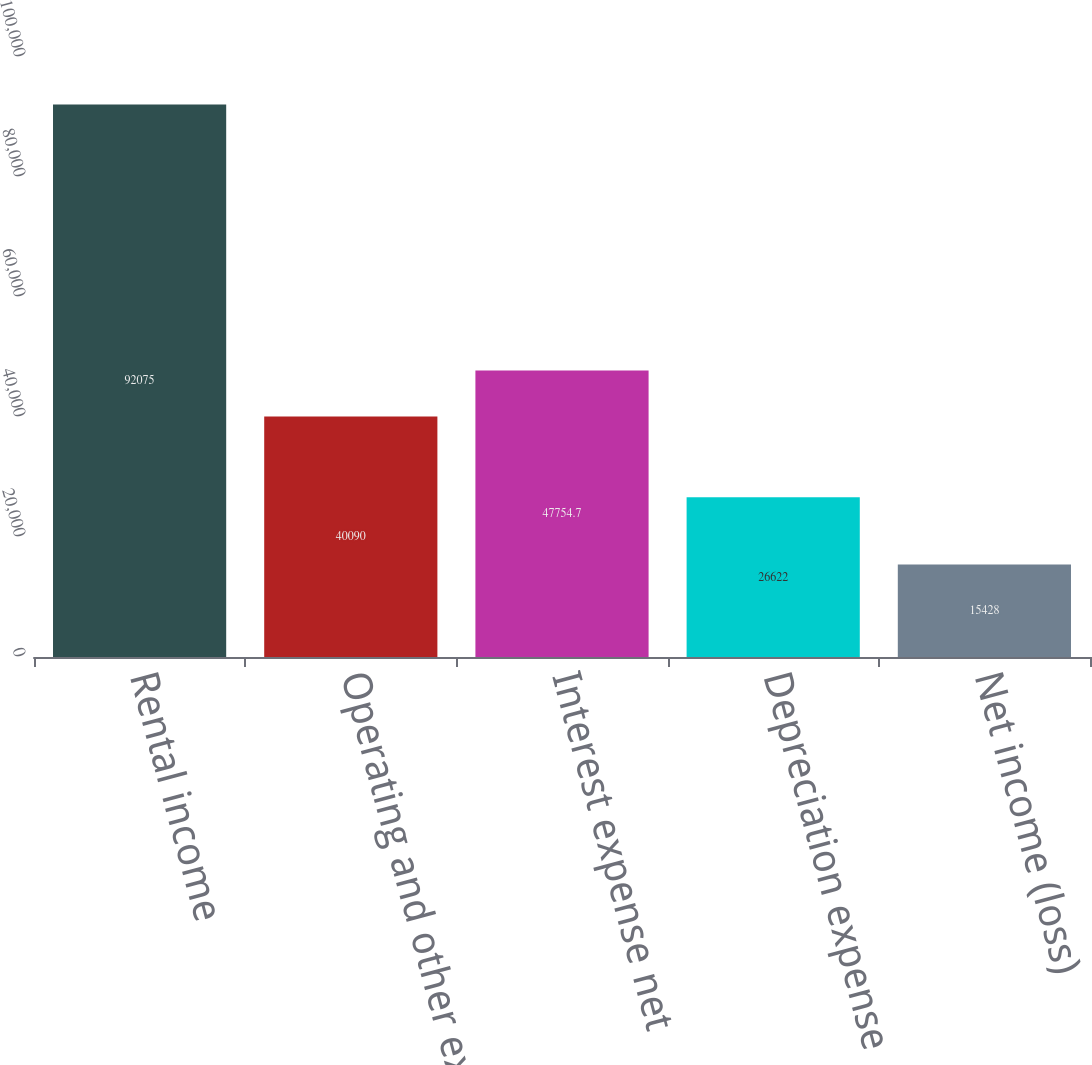<chart> <loc_0><loc_0><loc_500><loc_500><bar_chart><fcel>Rental income<fcel>Operating and other expenses<fcel>Interest expense net<fcel>Depreciation expense<fcel>Net income (loss)<nl><fcel>92075<fcel>40090<fcel>47754.7<fcel>26622<fcel>15428<nl></chart> 